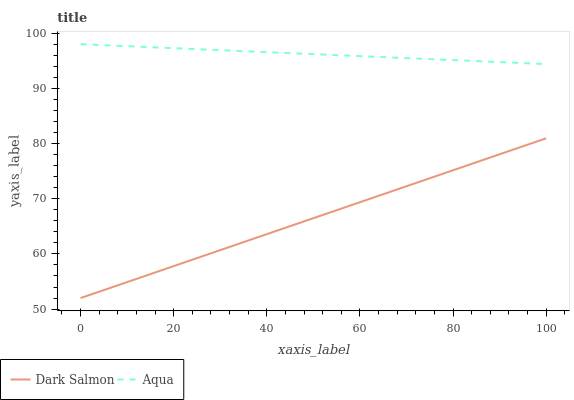Does Dark Salmon have the minimum area under the curve?
Answer yes or no. Yes. Does Aqua have the maximum area under the curve?
Answer yes or no. Yes. Does Dark Salmon have the maximum area under the curve?
Answer yes or no. No. Is Dark Salmon the smoothest?
Answer yes or no. Yes. Is Aqua the roughest?
Answer yes or no. Yes. Is Dark Salmon the roughest?
Answer yes or no. No. Does Dark Salmon have the lowest value?
Answer yes or no. Yes. Does Aqua have the highest value?
Answer yes or no. Yes. Does Dark Salmon have the highest value?
Answer yes or no. No. Is Dark Salmon less than Aqua?
Answer yes or no. Yes. Is Aqua greater than Dark Salmon?
Answer yes or no. Yes. Does Dark Salmon intersect Aqua?
Answer yes or no. No. 